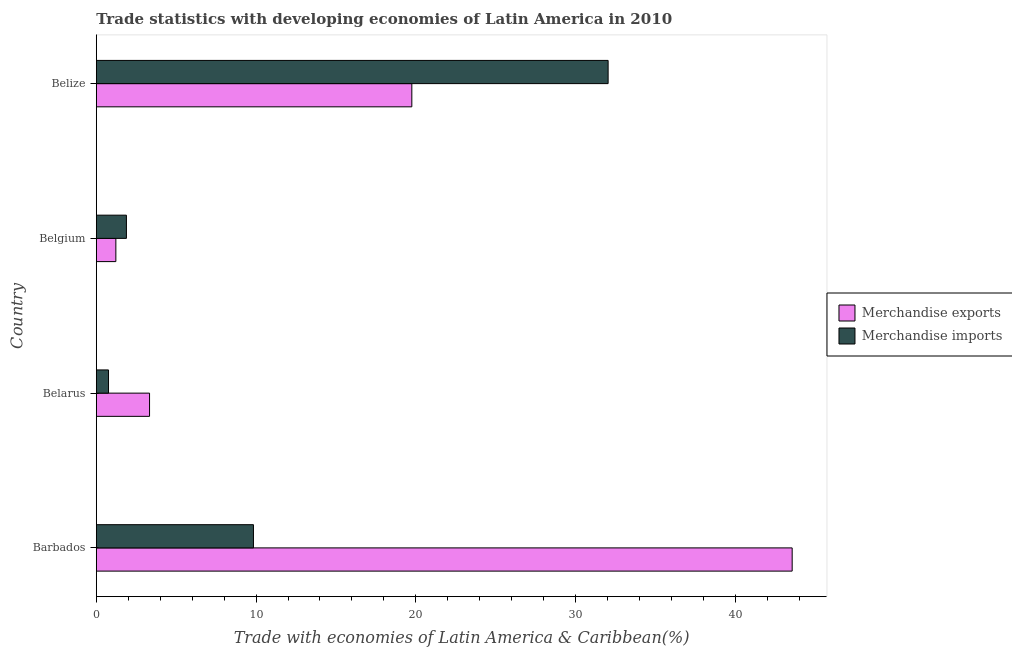Are the number of bars per tick equal to the number of legend labels?
Your response must be concise. Yes. Are the number of bars on each tick of the Y-axis equal?
Keep it short and to the point. Yes. How many bars are there on the 1st tick from the bottom?
Offer a very short reply. 2. In how many cases, is the number of bars for a given country not equal to the number of legend labels?
Provide a succinct answer. 0. What is the merchandise exports in Belgium?
Your answer should be compact. 1.22. Across all countries, what is the maximum merchandise imports?
Give a very brief answer. 32.05. Across all countries, what is the minimum merchandise imports?
Your answer should be compact. 0.76. In which country was the merchandise imports maximum?
Offer a very short reply. Belize. In which country was the merchandise exports minimum?
Your response must be concise. Belgium. What is the total merchandise exports in the graph?
Provide a short and direct response. 67.88. What is the difference between the merchandise imports in Barbados and that in Belize?
Give a very brief answer. -22.21. What is the difference between the merchandise imports in Belarus and the merchandise exports in Belize?
Keep it short and to the point. -18.99. What is the average merchandise exports per country?
Your answer should be compact. 16.97. What is the difference between the merchandise imports and merchandise exports in Barbados?
Give a very brief answer. -33.73. In how many countries, is the merchandise exports greater than 10 %?
Give a very brief answer. 2. What is the ratio of the merchandise imports in Belgium to that in Belize?
Provide a short and direct response. 0.06. Is the merchandise exports in Belgium less than that in Belize?
Give a very brief answer. Yes. What is the difference between the highest and the second highest merchandise exports?
Your answer should be very brief. 23.82. What is the difference between the highest and the lowest merchandise exports?
Offer a terse response. 42.35. In how many countries, is the merchandise imports greater than the average merchandise imports taken over all countries?
Offer a very short reply. 1. Is the sum of the merchandise exports in Barbados and Belarus greater than the maximum merchandise imports across all countries?
Offer a terse response. Yes. What does the 2nd bar from the top in Belize represents?
Provide a short and direct response. Merchandise exports. How many bars are there?
Your answer should be very brief. 8. Are all the bars in the graph horizontal?
Offer a terse response. Yes. Are the values on the major ticks of X-axis written in scientific E-notation?
Your answer should be compact. No. What is the title of the graph?
Provide a succinct answer. Trade statistics with developing economies of Latin America in 2010. Does "Revenue" appear as one of the legend labels in the graph?
Make the answer very short. No. What is the label or title of the X-axis?
Provide a short and direct response. Trade with economies of Latin America & Caribbean(%). What is the Trade with economies of Latin America & Caribbean(%) of Merchandise exports in Barbados?
Keep it short and to the point. 43.57. What is the Trade with economies of Latin America & Caribbean(%) in Merchandise imports in Barbados?
Offer a terse response. 9.84. What is the Trade with economies of Latin America & Caribbean(%) of Merchandise exports in Belarus?
Give a very brief answer. 3.33. What is the Trade with economies of Latin America & Caribbean(%) of Merchandise imports in Belarus?
Ensure brevity in your answer.  0.76. What is the Trade with economies of Latin America & Caribbean(%) of Merchandise exports in Belgium?
Keep it short and to the point. 1.22. What is the Trade with economies of Latin America & Caribbean(%) of Merchandise imports in Belgium?
Offer a very short reply. 1.88. What is the Trade with economies of Latin America & Caribbean(%) of Merchandise exports in Belize?
Make the answer very short. 19.75. What is the Trade with economies of Latin America & Caribbean(%) of Merchandise imports in Belize?
Your answer should be very brief. 32.05. Across all countries, what is the maximum Trade with economies of Latin America & Caribbean(%) in Merchandise exports?
Provide a short and direct response. 43.57. Across all countries, what is the maximum Trade with economies of Latin America & Caribbean(%) in Merchandise imports?
Keep it short and to the point. 32.05. Across all countries, what is the minimum Trade with economies of Latin America & Caribbean(%) of Merchandise exports?
Offer a very short reply. 1.22. Across all countries, what is the minimum Trade with economies of Latin America & Caribbean(%) in Merchandise imports?
Your response must be concise. 0.76. What is the total Trade with economies of Latin America & Caribbean(%) in Merchandise exports in the graph?
Your response must be concise. 67.88. What is the total Trade with economies of Latin America & Caribbean(%) in Merchandise imports in the graph?
Your answer should be very brief. 44.53. What is the difference between the Trade with economies of Latin America & Caribbean(%) of Merchandise exports in Barbados and that in Belarus?
Offer a very short reply. 40.24. What is the difference between the Trade with economies of Latin America & Caribbean(%) in Merchandise imports in Barbados and that in Belarus?
Provide a short and direct response. 9.08. What is the difference between the Trade with economies of Latin America & Caribbean(%) of Merchandise exports in Barbados and that in Belgium?
Ensure brevity in your answer.  42.35. What is the difference between the Trade with economies of Latin America & Caribbean(%) in Merchandise imports in Barbados and that in Belgium?
Make the answer very short. 7.95. What is the difference between the Trade with economies of Latin America & Caribbean(%) in Merchandise exports in Barbados and that in Belize?
Keep it short and to the point. 23.82. What is the difference between the Trade with economies of Latin America & Caribbean(%) in Merchandise imports in Barbados and that in Belize?
Provide a succinct answer. -22.21. What is the difference between the Trade with economies of Latin America & Caribbean(%) in Merchandise exports in Belarus and that in Belgium?
Your answer should be compact. 2.11. What is the difference between the Trade with economies of Latin America & Caribbean(%) of Merchandise imports in Belarus and that in Belgium?
Provide a succinct answer. -1.12. What is the difference between the Trade with economies of Latin America & Caribbean(%) in Merchandise exports in Belarus and that in Belize?
Provide a short and direct response. -16.42. What is the difference between the Trade with economies of Latin America & Caribbean(%) in Merchandise imports in Belarus and that in Belize?
Provide a short and direct response. -31.28. What is the difference between the Trade with economies of Latin America & Caribbean(%) in Merchandise exports in Belgium and that in Belize?
Provide a short and direct response. -18.53. What is the difference between the Trade with economies of Latin America & Caribbean(%) of Merchandise imports in Belgium and that in Belize?
Offer a very short reply. -30.16. What is the difference between the Trade with economies of Latin America & Caribbean(%) of Merchandise exports in Barbados and the Trade with economies of Latin America & Caribbean(%) of Merchandise imports in Belarus?
Give a very brief answer. 42.81. What is the difference between the Trade with economies of Latin America & Caribbean(%) in Merchandise exports in Barbados and the Trade with economies of Latin America & Caribbean(%) in Merchandise imports in Belgium?
Provide a short and direct response. 41.69. What is the difference between the Trade with economies of Latin America & Caribbean(%) in Merchandise exports in Barbados and the Trade with economies of Latin America & Caribbean(%) in Merchandise imports in Belize?
Your response must be concise. 11.52. What is the difference between the Trade with economies of Latin America & Caribbean(%) in Merchandise exports in Belarus and the Trade with economies of Latin America & Caribbean(%) in Merchandise imports in Belgium?
Provide a short and direct response. 1.45. What is the difference between the Trade with economies of Latin America & Caribbean(%) of Merchandise exports in Belarus and the Trade with economies of Latin America & Caribbean(%) of Merchandise imports in Belize?
Give a very brief answer. -28.71. What is the difference between the Trade with economies of Latin America & Caribbean(%) of Merchandise exports in Belgium and the Trade with economies of Latin America & Caribbean(%) of Merchandise imports in Belize?
Make the answer very short. -30.82. What is the average Trade with economies of Latin America & Caribbean(%) in Merchandise exports per country?
Provide a short and direct response. 16.97. What is the average Trade with economies of Latin America & Caribbean(%) in Merchandise imports per country?
Keep it short and to the point. 11.13. What is the difference between the Trade with economies of Latin America & Caribbean(%) of Merchandise exports and Trade with economies of Latin America & Caribbean(%) of Merchandise imports in Barbados?
Give a very brief answer. 33.73. What is the difference between the Trade with economies of Latin America & Caribbean(%) in Merchandise exports and Trade with economies of Latin America & Caribbean(%) in Merchandise imports in Belarus?
Make the answer very short. 2.57. What is the difference between the Trade with economies of Latin America & Caribbean(%) in Merchandise exports and Trade with economies of Latin America & Caribbean(%) in Merchandise imports in Belgium?
Give a very brief answer. -0.66. What is the difference between the Trade with economies of Latin America & Caribbean(%) of Merchandise exports and Trade with economies of Latin America & Caribbean(%) of Merchandise imports in Belize?
Offer a very short reply. -12.29. What is the ratio of the Trade with economies of Latin America & Caribbean(%) in Merchandise exports in Barbados to that in Belarus?
Your response must be concise. 13.08. What is the ratio of the Trade with economies of Latin America & Caribbean(%) of Merchandise imports in Barbados to that in Belarus?
Provide a short and direct response. 12.91. What is the ratio of the Trade with economies of Latin America & Caribbean(%) of Merchandise exports in Barbados to that in Belgium?
Make the answer very short. 35.65. What is the ratio of the Trade with economies of Latin America & Caribbean(%) of Merchandise imports in Barbados to that in Belgium?
Your answer should be very brief. 5.23. What is the ratio of the Trade with economies of Latin America & Caribbean(%) of Merchandise exports in Barbados to that in Belize?
Your response must be concise. 2.21. What is the ratio of the Trade with economies of Latin America & Caribbean(%) of Merchandise imports in Barbados to that in Belize?
Your response must be concise. 0.31. What is the ratio of the Trade with economies of Latin America & Caribbean(%) in Merchandise exports in Belarus to that in Belgium?
Your answer should be very brief. 2.73. What is the ratio of the Trade with economies of Latin America & Caribbean(%) of Merchandise imports in Belarus to that in Belgium?
Make the answer very short. 0.4. What is the ratio of the Trade with economies of Latin America & Caribbean(%) of Merchandise exports in Belarus to that in Belize?
Offer a very short reply. 0.17. What is the ratio of the Trade with economies of Latin America & Caribbean(%) in Merchandise imports in Belarus to that in Belize?
Make the answer very short. 0.02. What is the ratio of the Trade with economies of Latin America & Caribbean(%) in Merchandise exports in Belgium to that in Belize?
Make the answer very short. 0.06. What is the ratio of the Trade with economies of Latin America & Caribbean(%) in Merchandise imports in Belgium to that in Belize?
Ensure brevity in your answer.  0.06. What is the difference between the highest and the second highest Trade with economies of Latin America & Caribbean(%) in Merchandise exports?
Your answer should be very brief. 23.82. What is the difference between the highest and the second highest Trade with economies of Latin America & Caribbean(%) in Merchandise imports?
Provide a succinct answer. 22.21. What is the difference between the highest and the lowest Trade with economies of Latin America & Caribbean(%) of Merchandise exports?
Your answer should be very brief. 42.35. What is the difference between the highest and the lowest Trade with economies of Latin America & Caribbean(%) of Merchandise imports?
Your response must be concise. 31.28. 